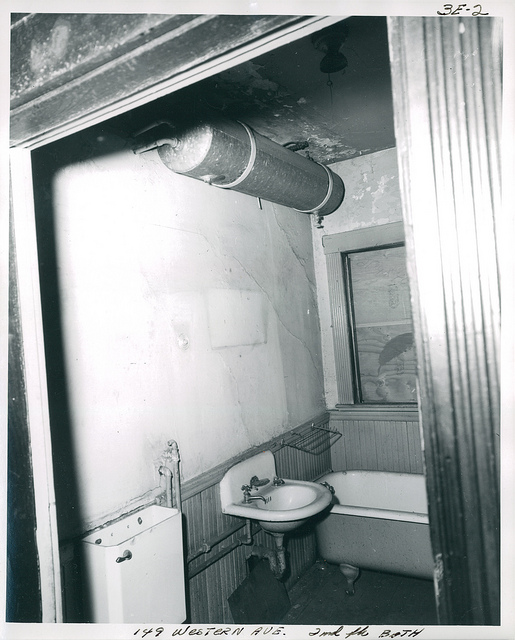What items are visible in this bathroom besides the sink? Besides the sink, you can see a bathtub with a shower head above, a medicine cabinet with a mirrored front above the sink, and a toilet to the left side of the image although it is partially obscured by the door frame. There also appears to be a pipe running across the top of the image, adding to the sense of clutter and compactness of the space. 